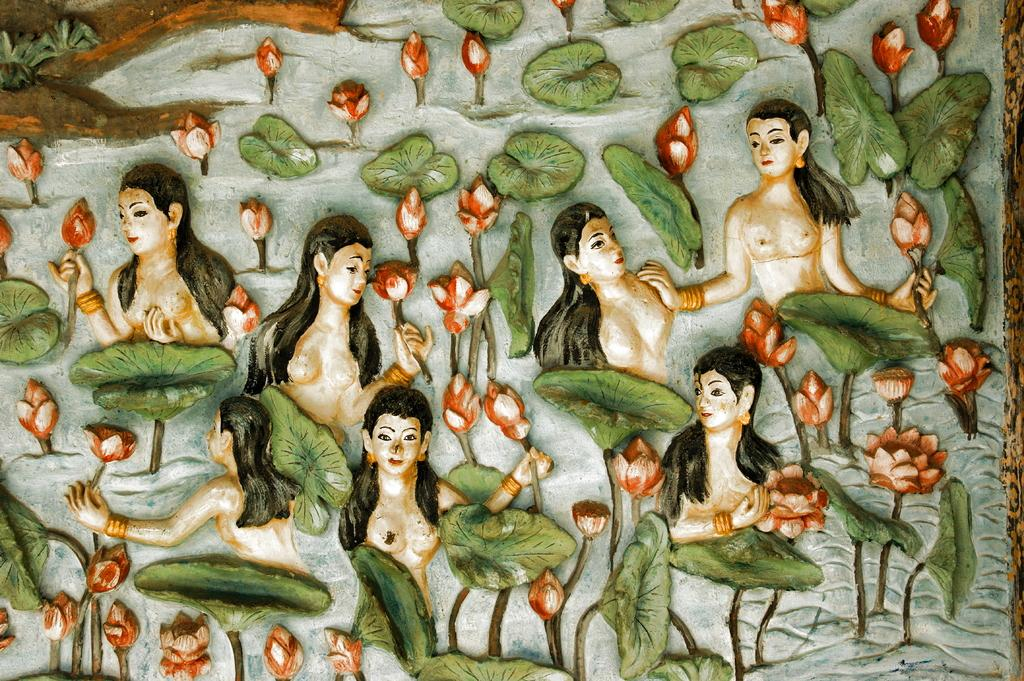What type of image is depicted in the art piece? The image appears to be an art piece. How many girls are present in the image? There are multiple girls in the image. What are the girls holding in the image? The girls are holding flowers in the image. What other elements can be seen in the image? There are leaves present in the image. What type of butter is being applied to the girls' lips in the image? There is no butter or lip application present in the image; the girls are holding flowers. 